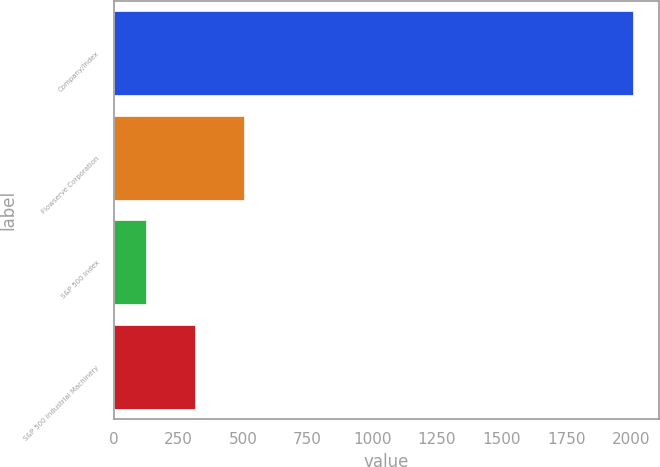Convert chart to OTSL. <chart><loc_0><loc_0><loc_500><loc_500><bar_chart><fcel>Company/Index<fcel>Flowserve Corporation<fcel>S&P 500 Index<fcel>S&P 500 Industrial Machinery<nl><fcel>2009<fcel>502.95<fcel>126.45<fcel>314.7<nl></chart> 